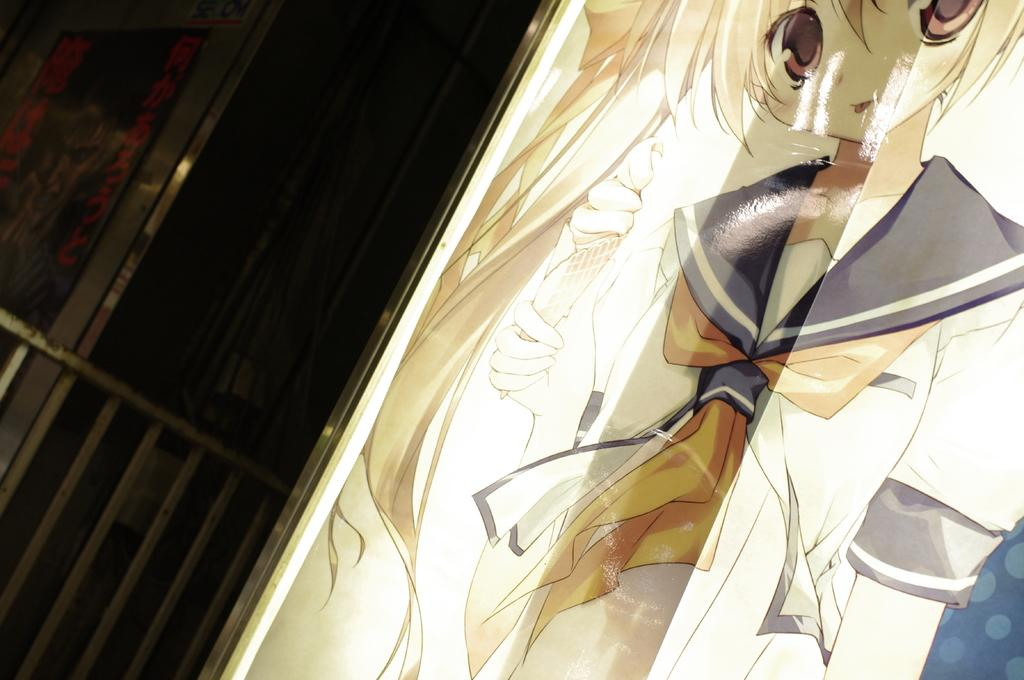What type of image can be seen on the right side of the image? There is a cartoon image on the right side of the image. What type of structure is on the left side of the image? There is a fence on the left side of the image. What type of opening is on the left side of the image? There is a door on the left side of the image. How many brothers are depicted in the cartoon image on the right side of the image? There is no information about any brothers in the image, as it only features a cartoon image and a fence and door on the left side. 